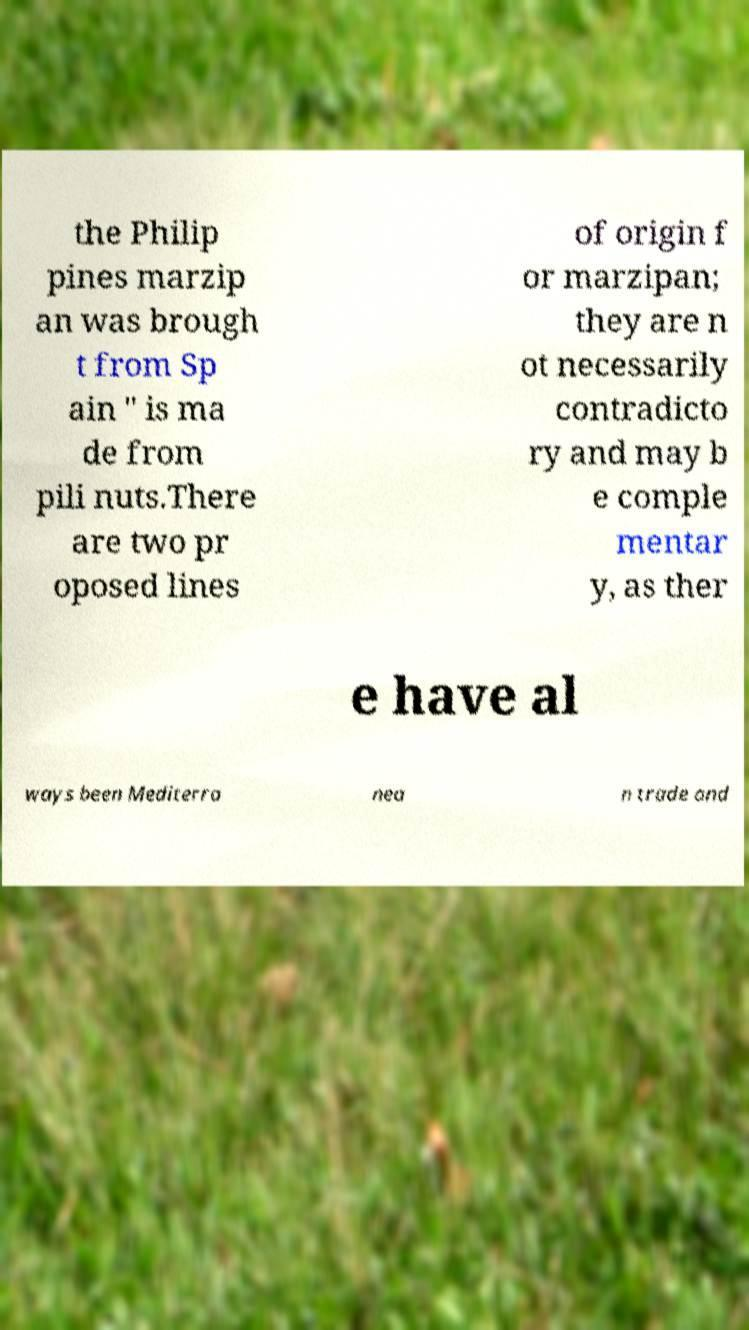I need the written content from this picture converted into text. Can you do that? the Philip pines marzip an was brough t from Sp ain " is ma de from pili nuts.There are two pr oposed lines of origin f or marzipan; they are n ot necessarily contradicto ry and may b e comple mentar y, as ther e have al ways been Mediterra nea n trade and 